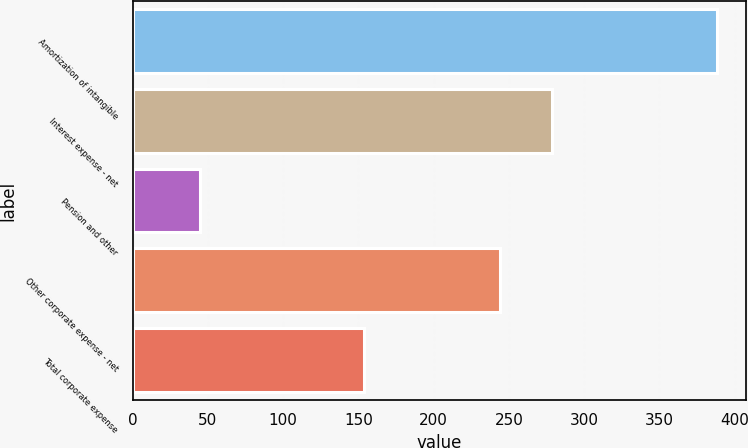Convert chart to OTSL. <chart><loc_0><loc_0><loc_500><loc_500><bar_chart><fcel>Amortization of intangible<fcel>Interest expense - net<fcel>Pension and other<fcel>Other corporate expense - net<fcel>Total corporate expense<nl><fcel>388<fcel>278.3<fcel>45<fcel>244<fcel>154<nl></chart> 